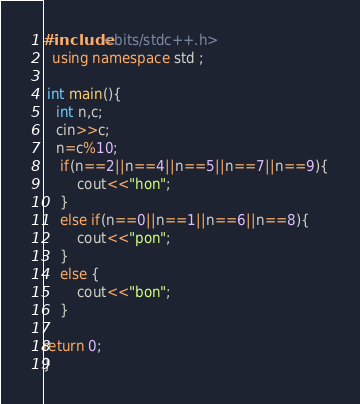<code> <loc_0><loc_0><loc_500><loc_500><_C++_>#include<bits/stdc++.h>
  using namespace std ;

 int main(){
   int n,c;
   cin>>c;
   n=c%10;
    if(n==2||n==4||n==5||n==7||n==9){
        cout<<"hon";
    }
    else if(n==0||n==1||n==6||n==8){
        cout<<"pon";
    }
    else {
        cout<<"bon";
    }

return 0;
}
</code> 